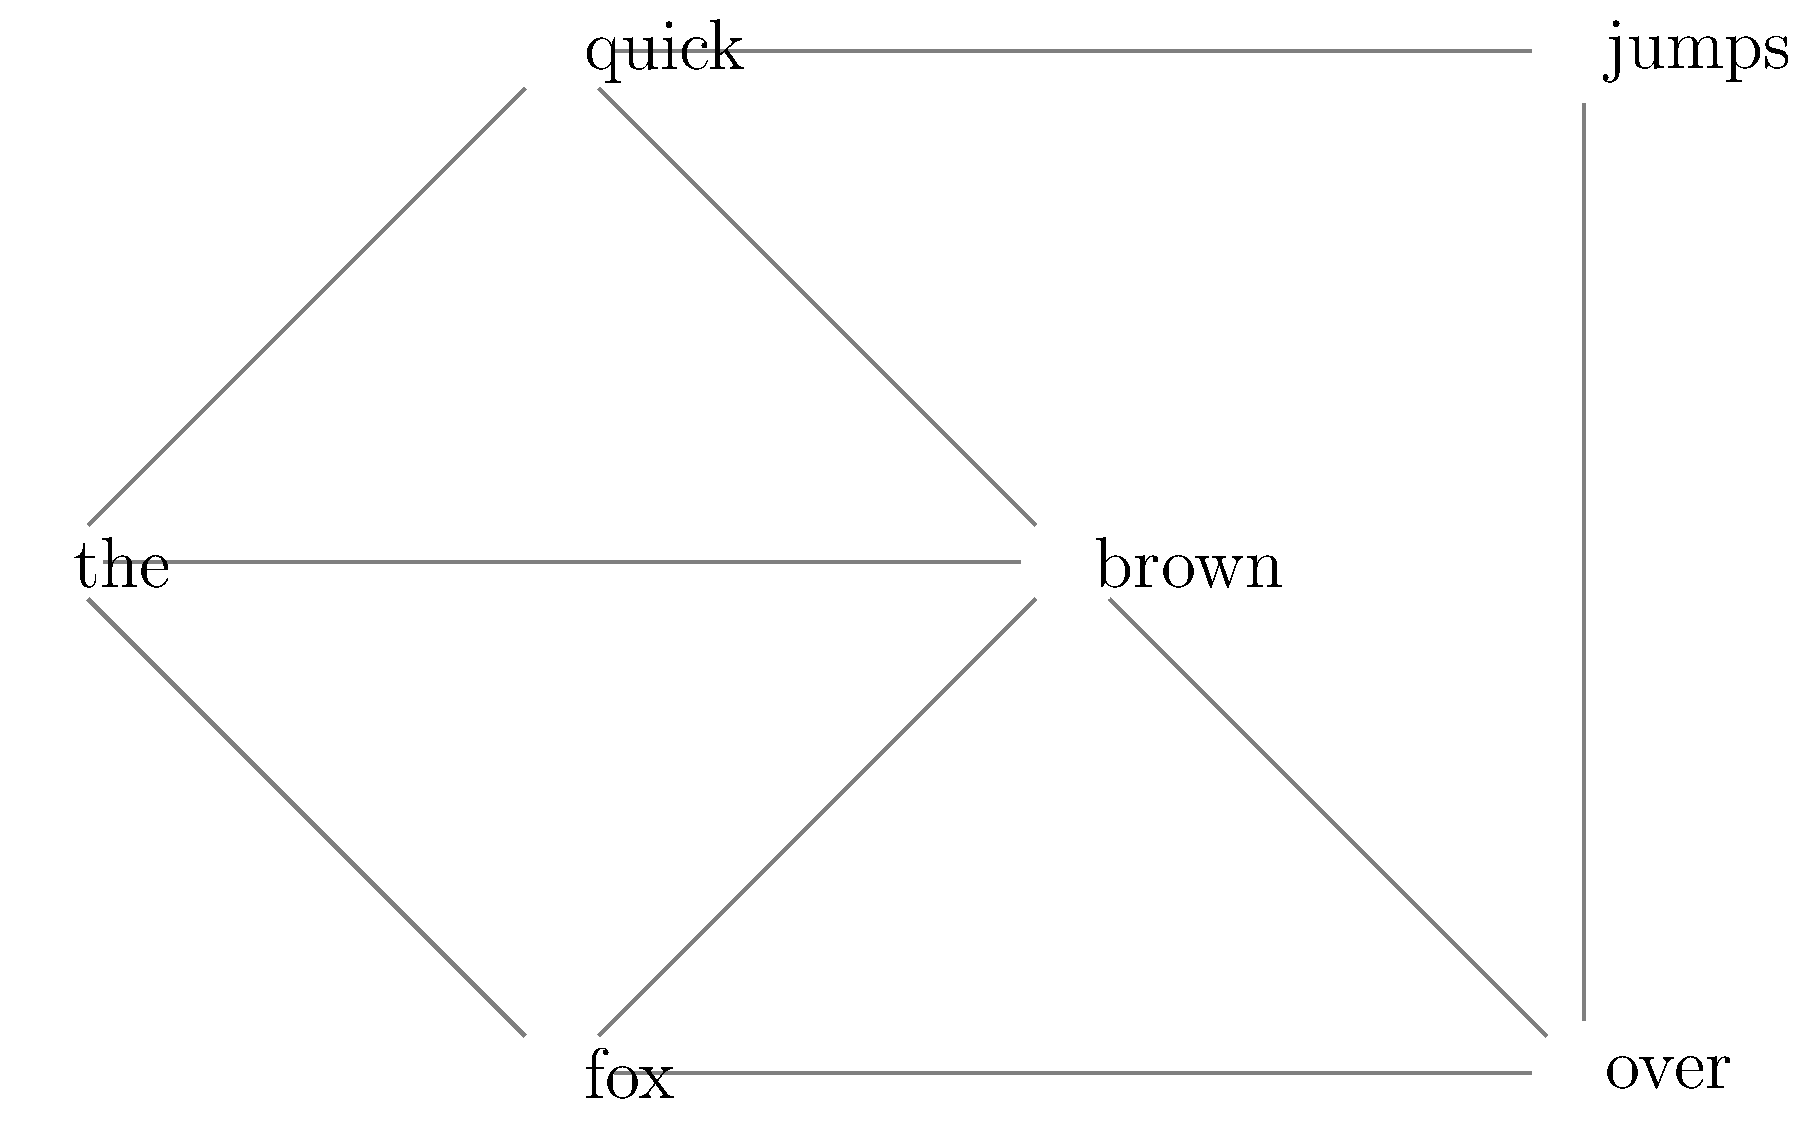In the force-directed graph representing word connections in a handwritten text, which word has the highest degree centrality, and what does this suggest about its role in the text's linguistic structure? To answer this question, we need to follow these steps:

1. Understand degree centrality: In graph theory, degree centrality is the number of edges connected to a node. In this context, it represents the number of direct connections a word has to other words in the text.

2. Count the connections for each word:
   - "the": 3 connections (to "quick", "brown", and "fox")
   - "quick": 3 connections (to "the", "brown", and "jumps")
   - "brown": 4 connections (to "the", "quick", "fox", and "over")
   - "fox": 3 connections (to "the", "brown", and "over")
   - "jumps": 2 connections (to "quick" and "over")
   - "over": 3 connections (to "brown", "fox", and "jumps")

3. Identify the word with the highest degree centrality: "brown" has the highest degree centrality with 4 connections.

4. Interpret the linguistic significance: The high degree centrality of "brown" suggests that it plays a central role in the text's structure. It likely serves as a key descriptive element or a pivotal point in the sentence, connecting various parts of the text together.

5. Consider the implications: In linguistic analysis, words with high degree centrality often indicate important concepts or themes in the text. They may be focal points for understanding the overall meaning or context of the handwritten document.
Answer: "brown"; central descriptive element connecting multiple parts of the text 